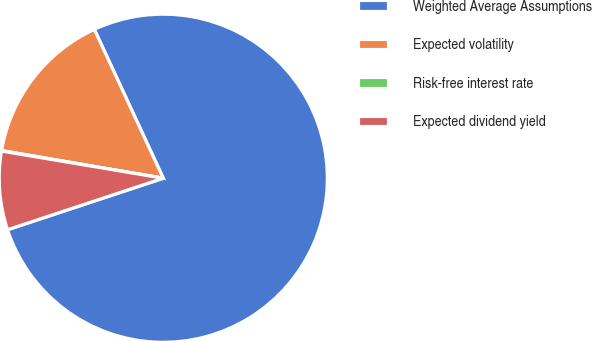Convert chart to OTSL. <chart><loc_0><loc_0><loc_500><loc_500><pie_chart><fcel>Weighted Average Assumptions<fcel>Expected volatility<fcel>Risk-free interest rate<fcel>Expected dividend yield<nl><fcel>76.82%<fcel>15.4%<fcel>0.05%<fcel>7.73%<nl></chart> 